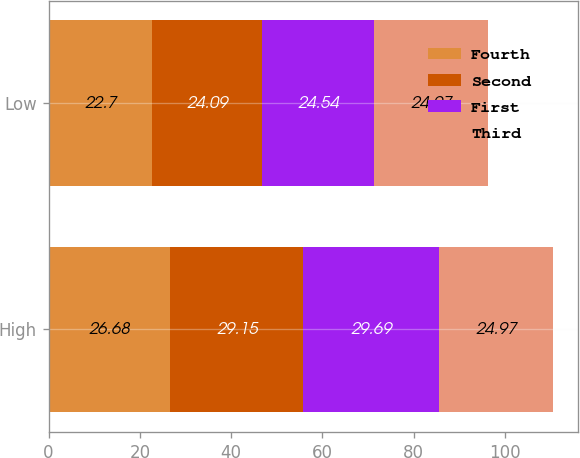<chart> <loc_0><loc_0><loc_500><loc_500><stacked_bar_chart><ecel><fcel>High<fcel>Low<nl><fcel>Fourth<fcel>26.68<fcel>22.7<nl><fcel>Second<fcel>29.15<fcel>24.09<nl><fcel>First<fcel>29.69<fcel>24.54<nl><fcel>Third<fcel>24.97<fcel>24.97<nl></chart> 